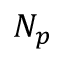<formula> <loc_0><loc_0><loc_500><loc_500>N _ { p }</formula> 